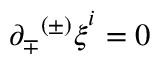<formula> <loc_0><loc_0><loc_500><loc_500>\partial _ { \mp } { ^ { ( \pm ) } \xi } ^ { i } = 0</formula> 